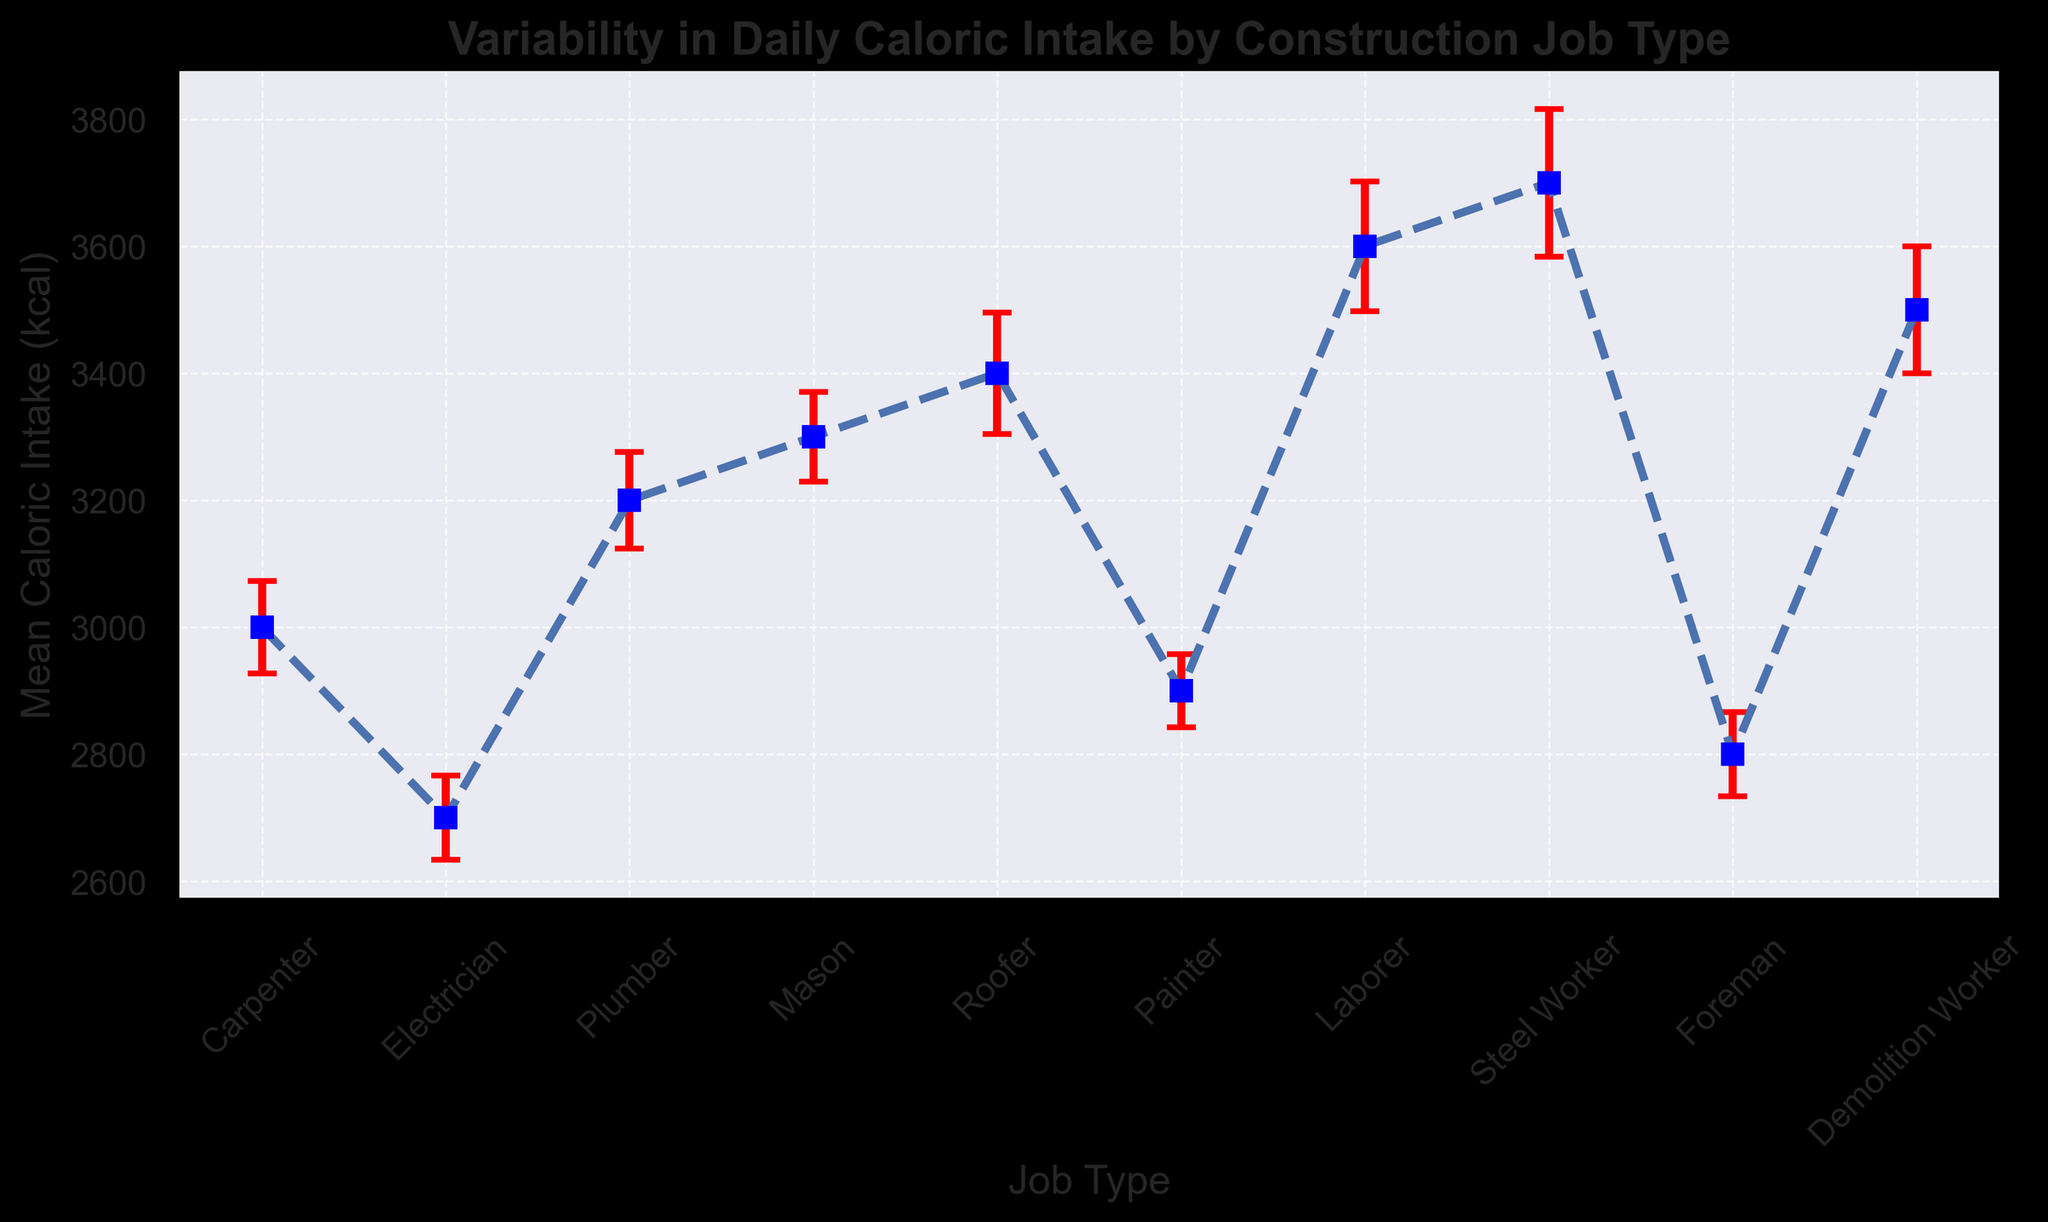Which job type has the highest mean caloric intake? The chart lists the mean caloric intakes for each job type. The job type with the highest mean caloric intake is visible at the top of the y-axis values. In this figure, Steel Worker has the highest mean caloric intake.
Answer: Steel Worker Which job type has the lowest mean caloric intake? The chart lists the mean caloric intakes for each job type. The job type with the lowest mean caloric intake is visible at the bottom of the y-axis values. In this figure, the Foreman has the lowest mean caloric intake.
Answer: Foreman What is the mean caloric intake difference between Laborer and Electrician? The mean caloric intake for Laborer is 3600 kcal, and for Electrician, it is 2700 kcal. The difference is 3600 - 2700 = 900 kcal.
Answer: 900 Which job type has the largest error bar, indicating the most variability in daily caloric intake? The error bars represent the standard error of the mean. The job type with the largest error bar can be identified by looking at which error bar extends the most on the figure. In this case, Steel Worker has the largest error bar.
Answer: Steel Worker Compare the mean caloric intakes of Plumber and Roofer. Which one is higher and by how much? The mean caloric intake for Plumber is 3200 kcal, and for Roofer, it is 3400 kcal. Roofer's mean caloric intake is higher by 3400 - 3200 = 200 kcal.
Answer: Roofer, 200 kcal By looking at the error bars, which job type has the least variability in daily caloric intake? The job type with the smallest error bar indicates the least variability in daily caloric intake. Painter has the smallest error bar.
Answer: Painter What is the average mean caloric intake of all job types shown? The mean caloric intakes are: 3000, 2700, 3200, 3300, 3400, 2900, 3600, 3700, 2800, 3500. Their sum is 34100 and there are 10 job types. So, the average mean caloric intake is 34100 / 10 = 3410 kcal.
Answer: 3410 kcal How does the mean caloric intake of a Demolition Worker compare to that of a Carpenter? The mean caloric intake of a Demolition Worker is 3500 kcal, and that of a Carpenter is 3000 kcal. The Demolition Worker has a higher mean caloric intake by 3500 - 3000 = 500 kcal.
Answer: 500 kcal 